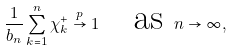Convert formula to latex. <formula><loc_0><loc_0><loc_500><loc_500>\frac { 1 } { b _ { n } } \sum _ { k = 1 } ^ { n } \chi _ { k } ^ { + } \overset { p } { \rightarrow } 1 \quad \text {as } n \rightarrow \infty ,</formula> 